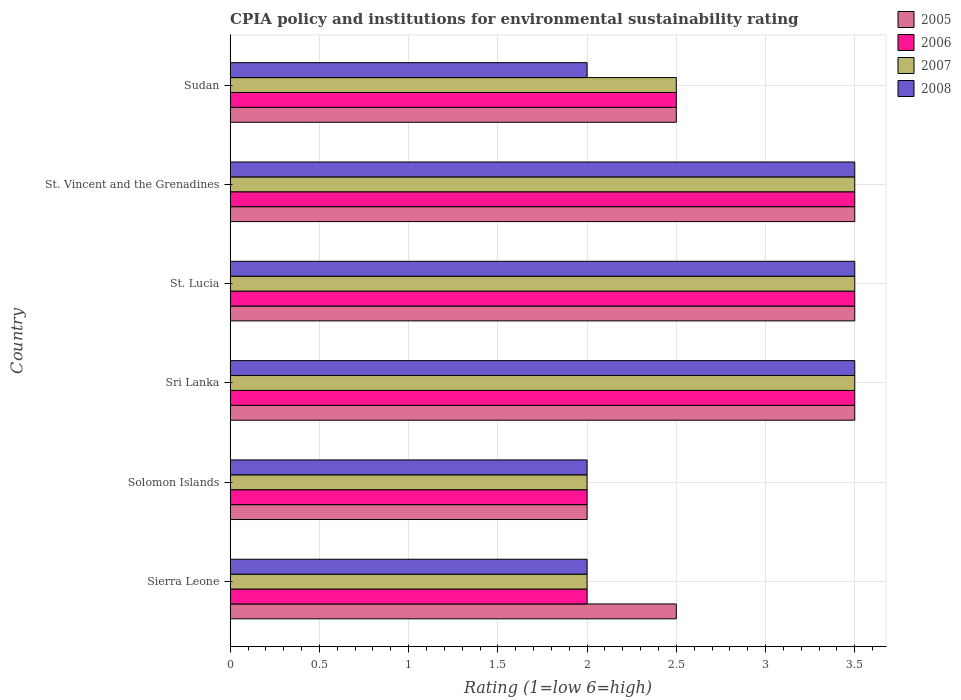Are the number of bars on each tick of the Y-axis equal?
Provide a succinct answer. Yes. How many bars are there on the 6th tick from the bottom?
Provide a short and direct response. 4. What is the label of the 6th group of bars from the top?
Your answer should be compact. Sierra Leone. In how many cases, is the number of bars for a given country not equal to the number of legend labels?
Make the answer very short. 0. In which country was the CPIA rating in 2006 maximum?
Keep it short and to the point. Sri Lanka. In which country was the CPIA rating in 2005 minimum?
Offer a terse response. Solomon Islands. What is the total CPIA rating in 2007 in the graph?
Offer a very short reply. 17. What is the difference between the CPIA rating in 2007 in St. Vincent and the Grenadines and the CPIA rating in 2008 in Sri Lanka?
Provide a succinct answer. 0. What is the average CPIA rating in 2005 per country?
Give a very brief answer. 2.92. What is the ratio of the CPIA rating in 2006 in Sierra Leone to that in Sudan?
Your answer should be very brief. 0.8. Is the difference between the CPIA rating in 2007 in Sierra Leone and Solomon Islands greater than the difference between the CPIA rating in 2006 in Sierra Leone and Solomon Islands?
Keep it short and to the point. No. What is the difference between the highest and the lowest CPIA rating in 2007?
Your answer should be compact. 1.5. Is the sum of the CPIA rating in 2007 in Sri Lanka and St. Lucia greater than the maximum CPIA rating in 2006 across all countries?
Keep it short and to the point. Yes. Is it the case that in every country, the sum of the CPIA rating in 2005 and CPIA rating in 2006 is greater than the sum of CPIA rating in 2007 and CPIA rating in 2008?
Your answer should be very brief. No. What does the 4th bar from the top in St. Lucia represents?
Offer a very short reply. 2005. What does the 2nd bar from the bottom in Sri Lanka represents?
Offer a terse response. 2006. Is it the case that in every country, the sum of the CPIA rating in 2007 and CPIA rating in 2008 is greater than the CPIA rating in 2006?
Your answer should be compact. Yes. How many bars are there?
Keep it short and to the point. 24. Are all the bars in the graph horizontal?
Your response must be concise. Yes. How many countries are there in the graph?
Give a very brief answer. 6. Are the values on the major ticks of X-axis written in scientific E-notation?
Give a very brief answer. No. Does the graph contain any zero values?
Your response must be concise. No. Does the graph contain grids?
Your response must be concise. Yes. Where does the legend appear in the graph?
Ensure brevity in your answer.  Top right. How many legend labels are there?
Provide a short and direct response. 4. How are the legend labels stacked?
Provide a short and direct response. Vertical. What is the title of the graph?
Make the answer very short. CPIA policy and institutions for environmental sustainability rating. Does "1993" appear as one of the legend labels in the graph?
Your answer should be compact. No. What is the label or title of the Y-axis?
Your answer should be compact. Country. What is the Rating (1=low 6=high) in 2006 in Sierra Leone?
Provide a short and direct response. 2. What is the Rating (1=low 6=high) in 2007 in Sierra Leone?
Provide a succinct answer. 2. What is the Rating (1=low 6=high) of 2005 in Solomon Islands?
Provide a succinct answer. 2. What is the Rating (1=low 6=high) of 2006 in Solomon Islands?
Your response must be concise. 2. What is the Rating (1=low 6=high) of 2007 in Solomon Islands?
Provide a short and direct response. 2. What is the Rating (1=low 6=high) of 2008 in Solomon Islands?
Ensure brevity in your answer.  2. What is the Rating (1=low 6=high) of 2006 in Sri Lanka?
Keep it short and to the point. 3.5. What is the Rating (1=low 6=high) in 2007 in Sri Lanka?
Make the answer very short. 3.5. What is the Rating (1=low 6=high) of 2008 in Sri Lanka?
Your answer should be very brief. 3.5. What is the Rating (1=low 6=high) in 2008 in St. Lucia?
Offer a very short reply. 3.5. What is the Rating (1=low 6=high) of 2005 in St. Vincent and the Grenadines?
Ensure brevity in your answer.  3.5. What is the Rating (1=low 6=high) in 2008 in St. Vincent and the Grenadines?
Make the answer very short. 3.5. What is the Rating (1=low 6=high) in 2005 in Sudan?
Provide a succinct answer. 2.5. What is the Rating (1=low 6=high) of 2008 in Sudan?
Ensure brevity in your answer.  2. Across all countries, what is the maximum Rating (1=low 6=high) in 2006?
Keep it short and to the point. 3.5. Across all countries, what is the maximum Rating (1=low 6=high) of 2008?
Ensure brevity in your answer.  3.5. Across all countries, what is the minimum Rating (1=low 6=high) in 2007?
Give a very brief answer. 2. What is the total Rating (1=low 6=high) in 2006 in the graph?
Give a very brief answer. 17. What is the difference between the Rating (1=low 6=high) of 2006 in Sierra Leone and that in Sri Lanka?
Offer a terse response. -1.5. What is the difference between the Rating (1=low 6=high) of 2008 in Sierra Leone and that in Sri Lanka?
Keep it short and to the point. -1.5. What is the difference between the Rating (1=low 6=high) in 2006 in Sierra Leone and that in St. Lucia?
Offer a terse response. -1.5. What is the difference between the Rating (1=low 6=high) of 2007 in Sierra Leone and that in St. Lucia?
Offer a terse response. -1.5. What is the difference between the Rating (1=low 6=high) in 2008 in Sierra Leone and that in St. Lucia?
Offer a very short reply. -1.5. What is the difference between the Rating (1=low 6=high) in 2007 in Sierra Leone and that in St. Vincent and the Grenadines?
Offer a very short reply. -1.5. What is the difference between the Rating (1=low 6=high) in 2008 in Sierra Leone and that in St. Vincent and the Grenadines?
Your answer should be very brief. -1.5. What is the difference between the Rating (1=low 6=high) of 2005 in Sierra Leone and that in Sudan?
Your answer should be compact. 0. What is the difference between the Rating (1=low 6=high) in 2007 in Sierra Leone and that in Sudan?
Keep it short and to the point. -0.5. What is the difference between the Rating (1=low 6=high) in 2008 in Sierra Leone and that in Sudan?
Offer a terse response. 0. What is the difference between the Rating (1=low 6=high) in 2007 in Solomon Islands and that in Sri Lanka?
Your response must be concise. -1.5. What is the difference between the Rating (1=low 6=high) of 2007 in Solomon Islands and that in St. Vincent and the Grenadines?
Provide a succinct answer. -1.5. What is the difference between the Rating (1=low 6=high) of 2005 in Solomon Islands and that in Sudan?
Provide a short and direct response. -0.5. What is the difference between the Rating (1=low 6=high) in 2005 in Sri Lanka and that in St. Lucia?
Keep it short and to the point. 0. What is the difference between the Rating (1=low 6=high) in 2007 in Sri Lanka and that in St. Lucia?
Your answer should be compact. 0. What is the difference between the Rating (1=low 6=high) in 2008 in Sri Lanka and that in St. Lucia?
Your answer should be very brief. 0. What is the difference between the Rating (1=low 6=high) of 2005 in Sri Lanka and that in St. Vincent and the Grenadines?
Give a very brief answer. 0. What is the difference between the Rating (1=low 6=high) of 2008 in Sri Lanka and that in Sudan?
Make the answer very short. 1.5. What is the difference between the Rating (1=low 6=high) of 2007 in St. Lucia and that in St. Vincent and the Grenadines?
Your answer should be very brief. 0. What is the difference between the Rating (1=low 6=high) in 2006 in St. Lucia and that in Sudan?
Ensure brevity in your answer.  1. What is the difference between the Rating (1=low 6=high) in 2007 in St. Lucia and that in Sudan?
Your response must be concise. 1. What is the difference between the Rating (1=low 6=high) in 2005 in St. Vincent and the Grenadines and that in Sudan?
Your answer should be compact. 1. What is the difference between the Rating (1=low 6=high) in 2006 in St. Vincent and the Grenadines and that in Sudan?
Your answer should be compact. 1. What is the difference between the Rating (1=low 6=high) in 2008 in St. Vincent and the Grenadines and that in Sudan?
Ensure brevity in your answer.  1.5. What is the difference between the Rating (1=low 6=high) of 2005 in Sierra Leone and the Rating (1=low 6=high) of 2006 in Solomon Islands?
Provide a short and direct response. 0.5. What is the difference between the Rating (1=low 6=high) in 2006 in Sierra Leone and the Rating (1=low 6=high) in 2007 in Sri Lanka?
Your response must be concise. -1.5. What is the difference between the Rating (1=low 6=high) in 2006 in Sierra Leone and the Rating (1=low 6=high) in 2008 in Sri Lanka?
Keep it short and to the point. -1.5. What is the difference between the Rating (1=low 6=high) of 2005 in Sierra Leone and the Rating (1=low 6=high) of 2007 in St. Lucia?
Offer a very short reply. -1. What is the difference between the Rating (1=low 6=high) of 2007 in Sierra Leone and the Rating (1=low 6=high) of 2008 in St. Lucia?
Provide a succinct answer. -1.5. What is the difference between the Rating (1=low 6=high) in 2005 in Sierra Leone and the Rating (1=low 6=high) in 2007 in St. Vincent and the Grenadines?
Ensure brevity in your answer.  -1. What is the difference between the Rating (1=low 6=high) in 2005 in Sierra Leone and the Rating (1=low 6=high) in 2008 in St. Vincent and the Grenadines?
Offer a very short reply. -1. What is the difference between the Rating (1=low 6=high) of 2006 in Sierra Leone and the Rating (1=low 6=high) of 2007 in St. Vincent and the Grenadines?
Ensure brevity in your answer.  -1.5. What is the difference between the Rating (1=low 6=high) of 2006 in Sierra Leone and the Rating (1=low 6=high) of 2008 in St. Vincent and the Grenadines?
Ensure brevity in your answer.  -1.5. What is the difference between the Rating (1=low 6=high) of 2005 in Sierra Leone and the Rating (1=low 6=high) of 2006 in Sudan?
Offer a very short reply. 0. What is the difference between the Rating (1=low 6=high) of 2005 in Sierra Leone and the Rating (1=low 6=high) of 2007 in Sudan?
Keep it short and to the point. 0. What is the difference between the Rating (1=low 6=high) in 2006 in Sierra Leone and the Rating (1=low 6=high) in 2008 in Sudan?
Offer a terse response. 0. What is the difference between the Rating (1=low 6=high) in 2005 in Solomon Islands and the Rating (1=low 6=high) in 2006 in Sri Lanka?
Give a very brief answer. -1.5. What is the difference between the Rating (1=low 6=high) of 2006 in Solomon Islands and the Rating (1=low 6=high) of 2008 in Sri Lanka?
Offer a terse response. -1.5. What is the difference between the Rating (1=low 6=high) of 2007 in Solomon Islands and the Rating (1=low 6=high) of 2008 in Sri Lanka?
Your answer should be compact. -1.5. What is the difference between the Rating (1=low 6=high) in 2005 in Solomon Islands and the Rating (1=low 6=high) in 2006 in St. Lucia?
Your answer should be compact. -1.5. What is the difference between the Rating (1=low 6=high) of 2005 in Solomon Islands and the Rating (1=low 6=high) of 2007 in St. Lucia?
Provide a succinct answer. -1.5. What is the difference between the Rating (1=low 6=high) of 2005 in Solomon Islands and the Rating (1=low 6=high) of 2008 in St. Lucia?
Offer a very short reply. -1.5. What is the difference between the Rating (1=low 6=high) in 2006 in Solomon Islands and the Rating (1=low 6=high) in 2007 in St. Lucia?
Give a very brief answer. -1.5. What is the difference between the Rating (1=low 6=high) in 2006 in Solomon Islands and the Rating (1=low 6=high) in 2008 in St. Lucia?
Provide a succinct answer. -1.5. What is the difference between the Rating (1=low 6=high) in 2005 in Solomon Islands and the Rating (1=low 6=high) in 2006 in St. Vincent and the Grenadines?
Give a very brief answer. -1.5. What is the difference between the Rating (1=low 6=high) of 2006 in Solomon Islands and the Rating (1=low 6=high) of 2007 in St. Vincent and the Grenadines?
Your answer should be very brief. -1.5. What is the difference between the Rating (1=low 6=high) of 2006 in Solomon Islands and the Rating (1=low 6=high) of 2008 in St. Vincent and the Grenadines?
Keep it short and to the point. -1.5. What is the difference between the Rating (1=low 6=high) of 2005 in Solomon Islands and the Rating (1=low 6=high) of 2006 in Sudan?
Make the answer very short. -0.5. What is the difference between the Rating (1=low 6=high) of 2005 in Solomon Islands and the Rating (1=low 6=high) of 2007 in Sudan?
Make the answer very short. -0.5. What is the difference between the Rating (1=low 6=high) in 2005 in Solomon Islands and the Rating (1=low 6=high) in 2008 in Sudan?
Make the answer very short. 0. What is the difference between the Rating (1=low 6=high) in 2006 in Solomon Islands and the Rating (1=low 6=high) in 2007 in Sudan?
Your response must be concise. -0.5. What is the difference between the Rating (1=low 6=high) of 2005 in Sri Lanka and the Rating (1=low 6=high) of 2006 in St. Lucia?
Your response must be concise. 0. What is the difference between the Rating (1=low 6=high) in 2005 in Sri Lanka and the Rating (1=low 6=high) in 2007 in St. Lucia?
Keep it short and to the point. 0. What is the difference between the Rating (1=low 6=high) of 2005 in Sri Lanka and the Rating (1=low 6=high) of 2008 in St. Lucia?
Give a very brief answer. 0. What is the difference between the Rating (1=low 6=high) in 2006 in Sri Lanka and the Rating (1=low 6=high) in 2007 in St. Lucia?
Ensure brevity in your answer.  0. What is the difference between the Rating (1=low 6=high) in 2007 in Sri Lanka and the Rating (1=low 6=high) in 2008 in St. Lucia?
Offer a terse response. 0. What is the difference between the Rating (1=low 6=high) of 2005 in Sri Lanka and the Rating (1=low 6=high) of 2006 in St. Vincent and the Grenadines?
Provide a succinct answer. 0. What is the difference between the Rating (1=low 6=high) in 2005 in Sri Lanka and the Rating (1=low 6=high) in 2007 in St. Vincent and the Grenadines?
Provide a succinct answer. 0. What is the difference between the Rating (1=low 6=high) in 2006 in Sri Lanka and the Rating (1=low 6=high) in 2008 in St. Vincent and the Grenadines?
Your response must be concise. 0. What is the difference between the Rating (1=low 6=high) in 2005 in Sri Lanka and the Rating (1=low 6=high) in 2006 in Sudan?
Your answer should be very brief. 1. What is the difference between the Rating (1=low 6=high) in 2005 in Sri Lanka and the Rating (1=low 6=high) in 2007 in Sudan?
Provide a succinct answer. 1. What is the difference between the Rating (1=low 6=high) of 2006 in Sri Lanka and the Rating (1=low 6=high) of 2007 in Sudan?
Offer a very short reply. 1. What is the difference between the Rating (1=low 6=high) in 2007 in Sri Lanka and the Rating (1=low 6=high) in 2008 in Sudan?
Your response must be concise. 1.5. What is the difference between the Rating (1=low 6=high) of 2005 in St. Vincent and the Grenadines and the Rating (1=low 6=high) of 2006 in Sudan?
Give a very brief answer. 1. What is the difference between the Rating (1=low 6=high) of 2006 in St. Vincent and the Grenadines and the Rating (1=low 6=high) of 2007 in Sudan?
Your answer should be compact. 1. What is the average Rating (1=low 6=high) of 2005 per country?
Provide a succinct answer. 2.92. What is the average Rating (1=low 6=high) in 2006 per country?
Offer a very short reply. 2.83. What is the average Rating (1=low 6=high) in 2007 per country?
Provide a succinct answer. 2.83. What is the average Rating (1=low 6=high) of 2008 per country?
Keep it short and to the point. 2.75. What is the difference between the Rating (1=low 6=high) in 2005 and Rating (1=low 6=high) in 2007 in Sierra Leone?
Offer a very short reply. 0.5. What is the difference between the Rating (1=low 6=high) in 2005 and Rating (1=low 6=high) in 2008 in Sierra Leone?
Offer a very short reply. 0.5. What is the difference between the Rating (1=low 6=high) in 2006 and Rating (1=low 6=high) in 2008 in Sierra Leone?
Give a very brief answer. 0. What is the difference between the Rating (1=low 6=high) of 2007 and Rating (1=low 6=high) of 2008 in Sierra Leone?
Offer a very short reply. 0. What is the difference between the Rating (1=low 6=high) of 2005 and Rating (1=low 6=high) of 2006 in Solomon Islands?
Your response must be concise. 0. What is the difference between the Rating (1=low 6=high) in 2006 and Rating (1=low 6=high) in 2008 in Solomon Islands?
Your response must be concise. 0. What is the difference between the Rating (1=low 6=high) in 2007 and Rating (1=low 6=high) in 2008 in Solomon Islands?
Your answer should be compact. 0. What is the difference between the Rating (1=low 6=high) of 2005 and Rating (1=low 6=high) of 2008 in Sri Lanka?
Your answer should be compact. 0. What is the difference between the Rating (1=low 6=high) of 2006 and Rating (1=low 6=high) of 2007 in Sri Lanka?
Keep it short and to the point. 0. What is the difference between the Rating (1=low 6=high) of 2005 and Rating (1=low 6=high) of 2006 in St. Lucia?
Offer a terse response. 0. What is the difference between the Rating (1=low 6=high) in 2005 and Rating (1=low 6=high) in 2007 in St. Lucia?
Give a very brief answer. 0. What is the difference between the Rating (1=low 6=high) of 2006 and Rating (1=low 6=high) of 2007 in St. Lucia?
Offer a terse response. 0. What is the difference between the Rating (1=low 6=high) of 2006 and Rating (1=low 6=high) of 2008 in St. Lucia?
Provide a short and direct response. 0. What is the difference between the Rating (1=low 6=high) in 2007 and Rating (1=low 6=high) in 2008 in St. Lucia?
Your answer should be compact. 0. What is the difference between the Rating (1=low 6=high) of 2005 and Rating (1=low 6=high) of 2008 in St. Vincent and the Grenadines?
Your response must be concise. 0. What is the difference between the Rating (1=low 6=high) in 2006 and Rating (1=low 6=high) in 2007 in St. Vincent and the Grenadines?
Provide a short and direct response. 0. What is the difference between the Rating (1=low 6=high) in 2005 and Rating (1=low 6=high) in 2006 in Sudan?
Keep it short and to the point. 0. What is the difference between the Rating (1=low 6=high) of 2005 and Rating (1=low 6=high) of 2007 in Sudan?
Keep it short and to the point. 0. What is the difference between the Rating (1=low 6=high) of 2005 and Rating (1=low 6=high) of 2008 in Sudan?
Give a very brief answer. 0.5. What is the difference between the Rating (1=low 6=high) of 2006 and Rating (1=low 6=high) of 2007 in Sudan?
Ensure brevity in your answer.  0. What is the ratio of the Rating (1=low 6=high) in 2005 in Sierra Leone to that in Solomon Islands?
Offer a terse response. 1.25. What is the ratio of the Rating (1=low 6=high) in 2006 in Sierra Leone to that in Solomon Islands?
Offer a very short reply. 1. What is the ratio of the Rating (1=low 6=high) in 2007 in Sierra Leone to that in Solomon Islands?
Your response must be concise. 1. What is the ratio of the Rating (1=low 6=high) of 2007 in Sierra Leone to that in Sri Lanka?
Your answer should be very brief. 0.57. What is the ratio of the Rating (1=low 6=high) in 2008 in Sierra Leone to that in Sri Lanka?
Your answer should be very brief. 0.57. What is the ratio of the Rating (1=low 6=high) of 2008 in Sierra Leone to that in St. Lucia?
Give a very brief answer. 0.57. What is the ratio of the Rating (1=low 6=high) in 2006 in Sierra Leone to that in St. Vincent and the Grenadines?
Your answer should be very brief. 0.57. What is the ratio of the Rating (1=low 6=high) in 2008 in Sierra Leone to that in St. Vincent and the Grenadines?
Provide a short and direct response. 0.57. What is the ratio of the Rating (1=low 6=high) of 2005 in Sierra Leone to that in Sudan?
Provide a short and direct response. 1. What is the ratio of the Rating (1=low 6=high) in 2005 in Solomon Islands to that in Sri Lanka?
Your answer should be compact. 0.57. What is the ratio of the Rating (1=low 6=high) in 2008 in Solomon Islands to that in Sri Lanka?
Make the answer very short. 0.57. What is the ratio of the Rating (1=low 6=high) of 2005 in Solomon Islands to that in St. Lucia?
Your answer should be very brief. 0.57. What is the ratio of the Rating (1=low 6=high) of 2006 in Solomon Islands to that in St. Lucia?
Your answer should be very brief. 0.57. What is the ratio of the Rating (1=low 6=high) in 2008 in Solomon Islands to that in St. Lucia?
Keep it short and to the point. 0.57. What is the ratio of the Rating (1=low 6=high) in 2006 in Solomon Islands to that in Sudan?
Your answer should be compact. 0.8. What is the ratio of the Rating (1=low 6=high) of 2007 in Solomon Islands to that in Sudan?
Make the answer very short. 0.8. What is the ratio of the Rating (1=low 6=high) of 2007 in Sri Lanka to that in St. Lucia?
Your answer should be compact. 1. What is the ratio of the Rating (1=low 6=high) of 2005 in Sri Lanka to that in St. Vincent and the Grenadines?
Offer a terse response. 1. What is the ratio of the Rating (1=low 6=high) in 2007 in Sri Lanka to that in St. Vincent and the Grenadines?
Your response must be concise. 1. What is the ratio of the Rating (1=low 6=high) in 2008 in Sri Lanka to that in St. Vincent and the Grenadines?
Offer a very short reply. 1. What is the ratio of the Rating (1=low 6=high) of 2006 in Sri Lanka to that in Sudan?
Make the answer very short. 1.4. What is the ratio of the Rating (1=low 6=high) in 2007 in Sri Lanka to that in Sudan?
Make the answer very short. 1.4. What is the ratio of the Rating (1=low 6=high) in 2005 in St. Lucia to that in St. Vincent and the Grenadines?
Offer a terse response. 1. What is the ratio of the Rating (1=low 6=high) in 2008 in St. Lucia to that in St. Vincent and the Grenadines?
Offer a very short reply. 1. What is the ratio of the Rating (1=low 6=high) of 2005 in St. Lucia to that in Sudan?
Your answer should be compact. 1.4. What is the ratio of the Rating (1=low 6=high) in 2005 in St. Vincent and the Grenadines to that in Sudan?
Provide a short and direct response. 1.4. What is the ratio of the Rating (1=low 6=high) in 2007 in St. Vincent and the Grenadines to that in Sudan?
Offer a terse response. 1.4. What is the ratio of the Rating (1=low 6=high) in 2008 in St. Vincent and the Grenadines to that in Sudan?
Keep it short and to the point. 1.75. What is the difference between the highest and the second highest Rating (1=low 6=high) of 2008?
Offer a very short reply. 0. What is the difference between the highest and the lowest Rating (1=low 6=high) in 2006?
Provide a short and direct response. 1.5. What is the difference between the highest and the lowest Rating (1=low 6=high) of 2007?
Keep it short and to the point. 1.5. What is the difference between the highest and the lowest Rating (1=low 6=high) of 2008?
Offer a terse response. 1.5. 